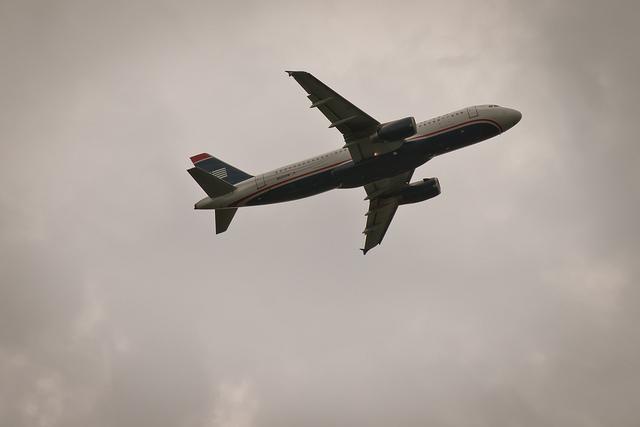Is it a cloudy day?
Short answer required. Yes. Is the plane still on the runway?
Keep it brief. No. Is sunny or overcast?
Answer briefly. Overcast. Is it a sunny day?
Give a very brief answer. No. Is this plane in motion?
Keep it brief. Yes. 